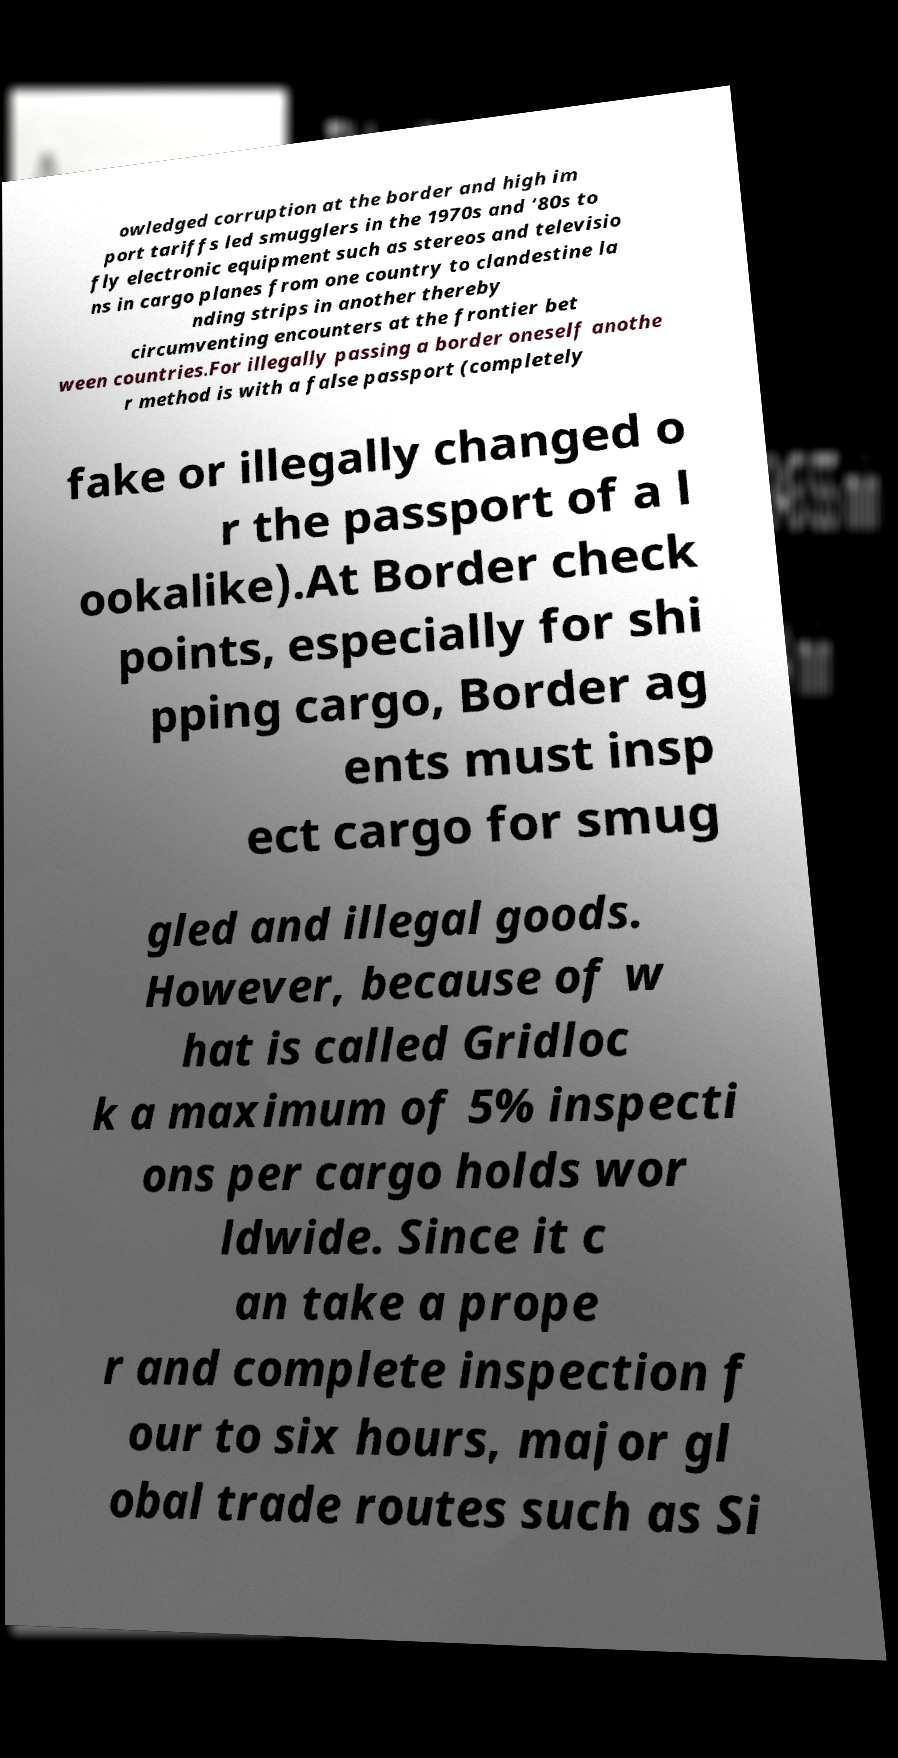Please identify and transcribe the text found in this image. owledged corruption at the border and high im port tariffs led smugglers in the 1970s and ‘80s to fly electronic equipment such as stereos and televisio ns in cargo planes from one country to clandestine la nding strips in another thereby circumventing encounters at the frontier bet ween countries.For illegally passing a border oneself anothe r method is with a false passport (completely fake or illegally changed o r the passport of a l ookalike).At Border check points, especially for shi pping cargo, Border ag ents must insp ect cargo for smug gled and illegal goods. However, because of w hat is called Gridloc k a maximum of 5% inspecti ons per cargo holds wor ldwide. Since it c an take a prope r and complete inspection f our to six hours, major gl obal trade routes such as Si 